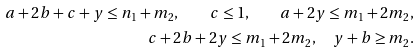Convert formula to latex. <formula><loc_0><loc_0><loc_500><loc_500>a + 2 b + c + y \leq n _ { 1 } + m _ { 2 } , \quad c \leq 1 , \quad a + 2 y \leq m _ { 1 } + 2 m _ { 2 } , \\ c + 2 b + 2 y \leq m _ { 1 } + 2 m _ { 2 } , \quad y + b \geq m _ { 2 } .</formula> 